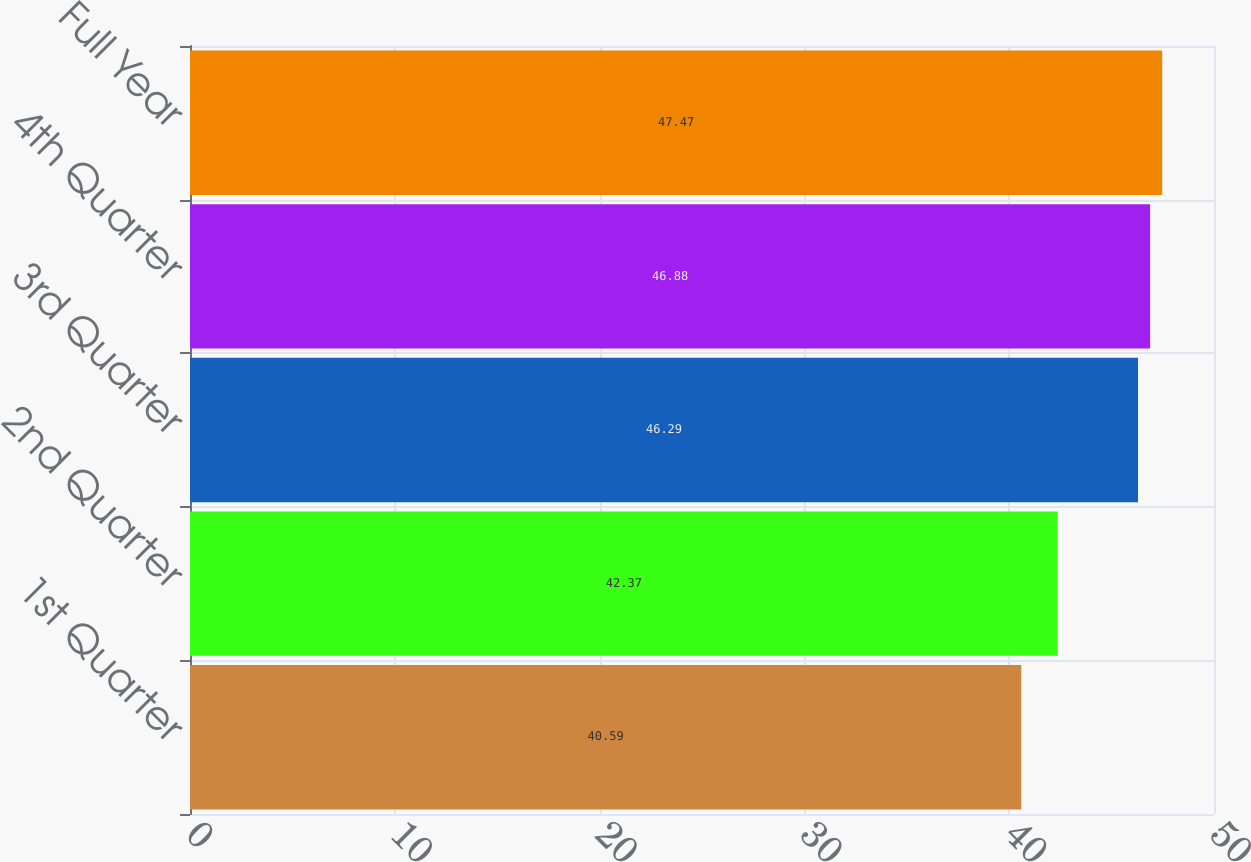Convert chart. <chart><loc_0><loc_0><loc_500><loc_500><bar_chart><fcel>1st Quarter<fcel>2nd Quarter<fcel>3rd Quarter<fcel>4th Quarter<fcel>Full Year<nl><fcel>40.59<fcel>42.37<fcel>46.29<fcel>46.88<fcel>47.47<nl></chart> 